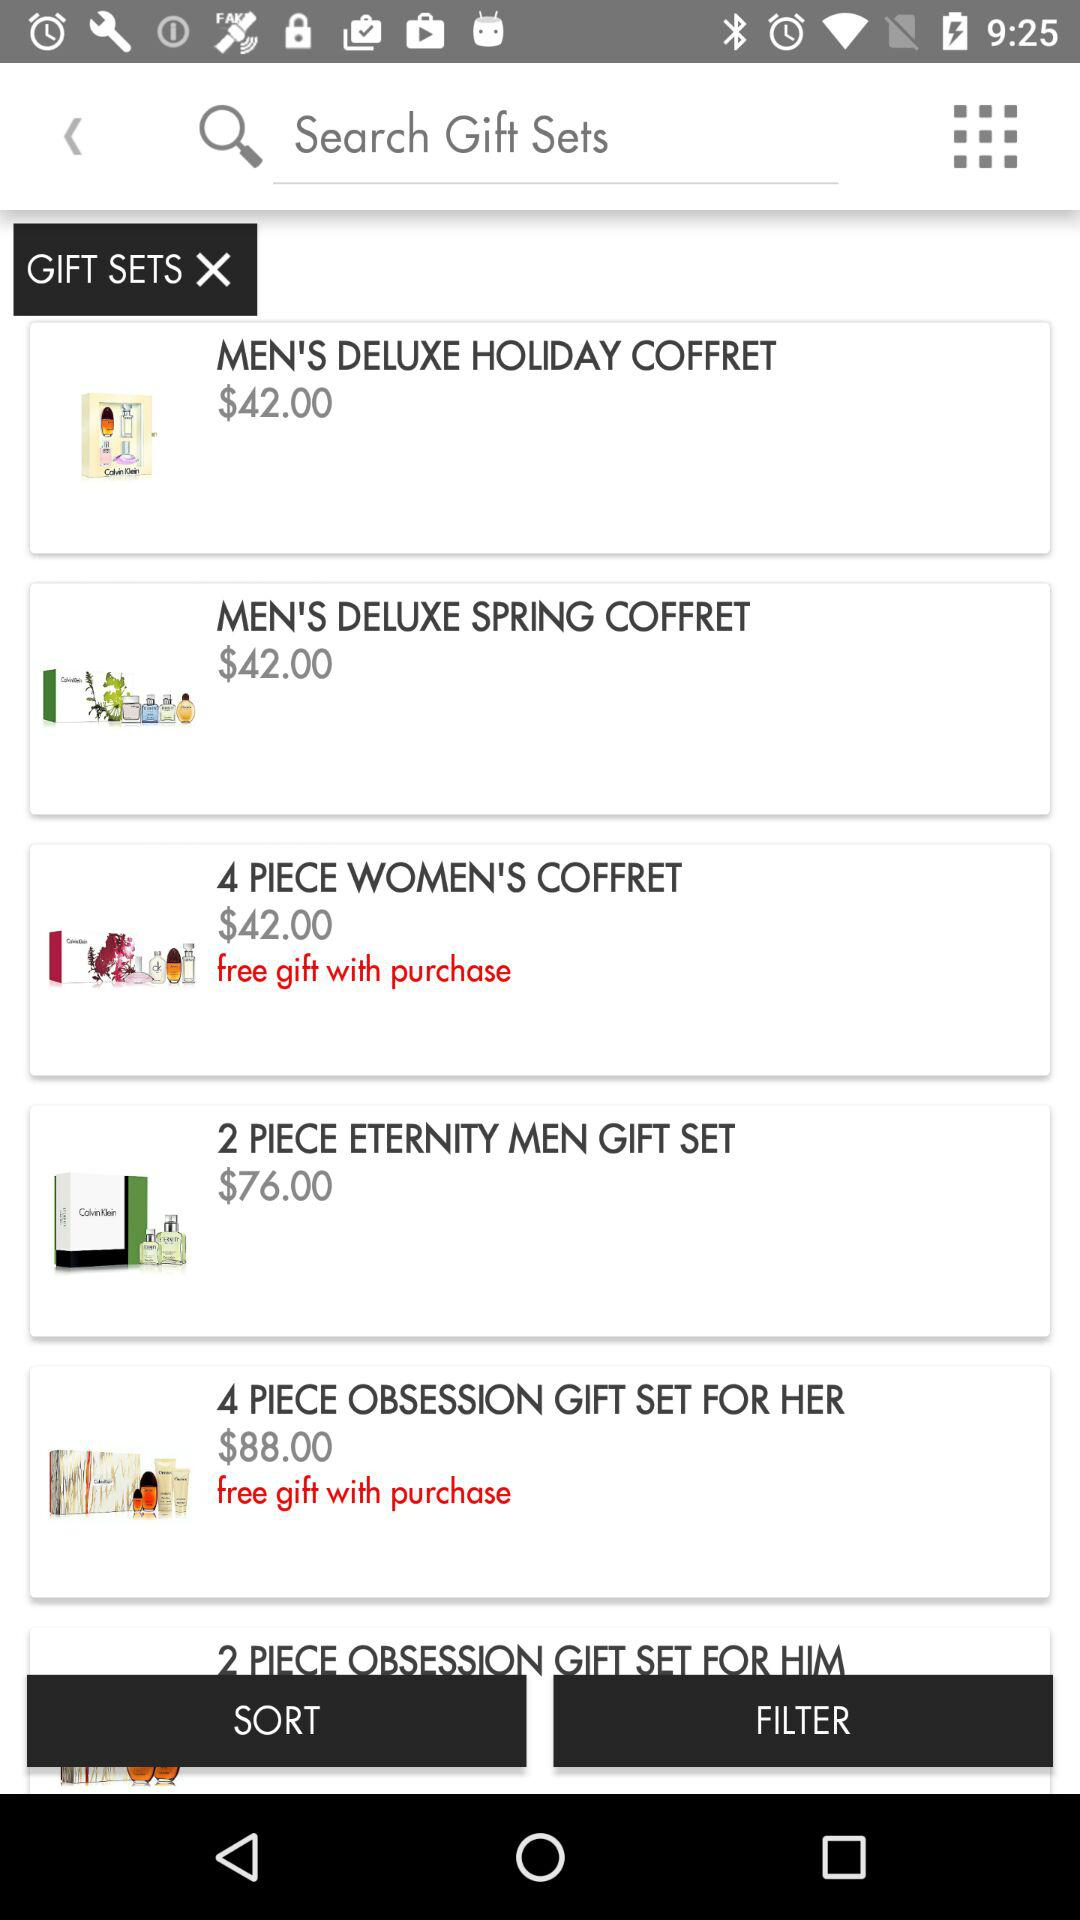What is the price of "MEN'S DELUXE HOLIDAY COFFRET"? The price of "MEN'S DELUXE HOLIDAY COFFRET" is $42.00. 